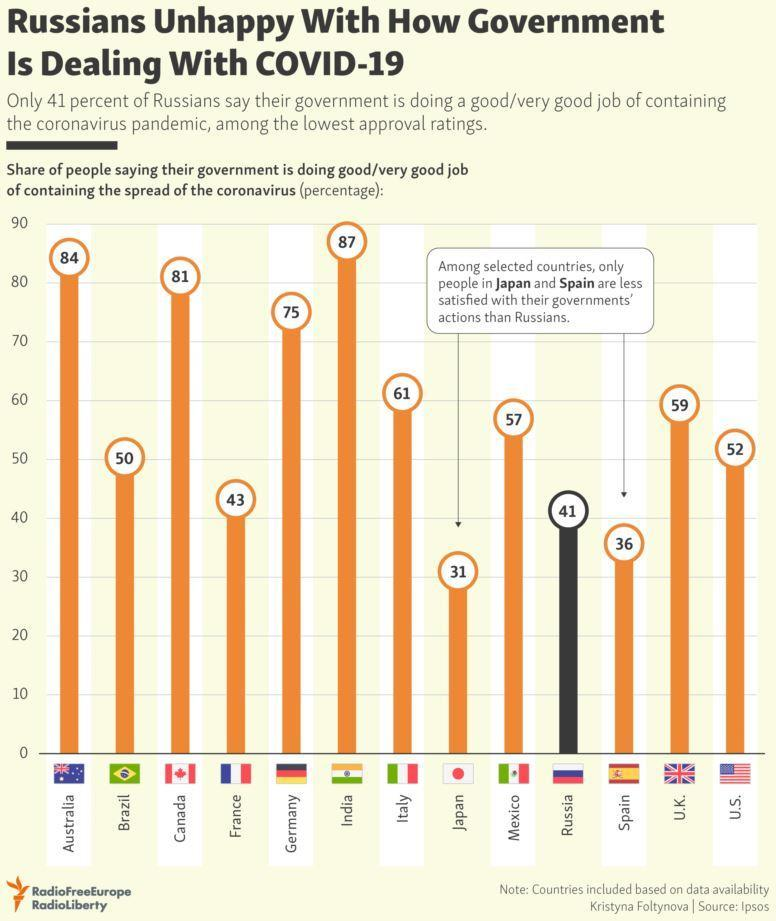What percentage of people in Germany say that their government is doing a good job in containing the spread of the coronavirus?
Answer the question with a short phrase. 75 What percentage of people in India say that their government is doing a good job in containing the spread of the coronavirus? 87 Which country is most satisfied with their governments' actions among the selected countries? India What percentage of people in the U.S. say that their government is doing a good job in containing the spread of the coronavirus? 52 Which two countries are less satisfied with their governments' actions than Russians, among the selected countries? Japan, Spain 